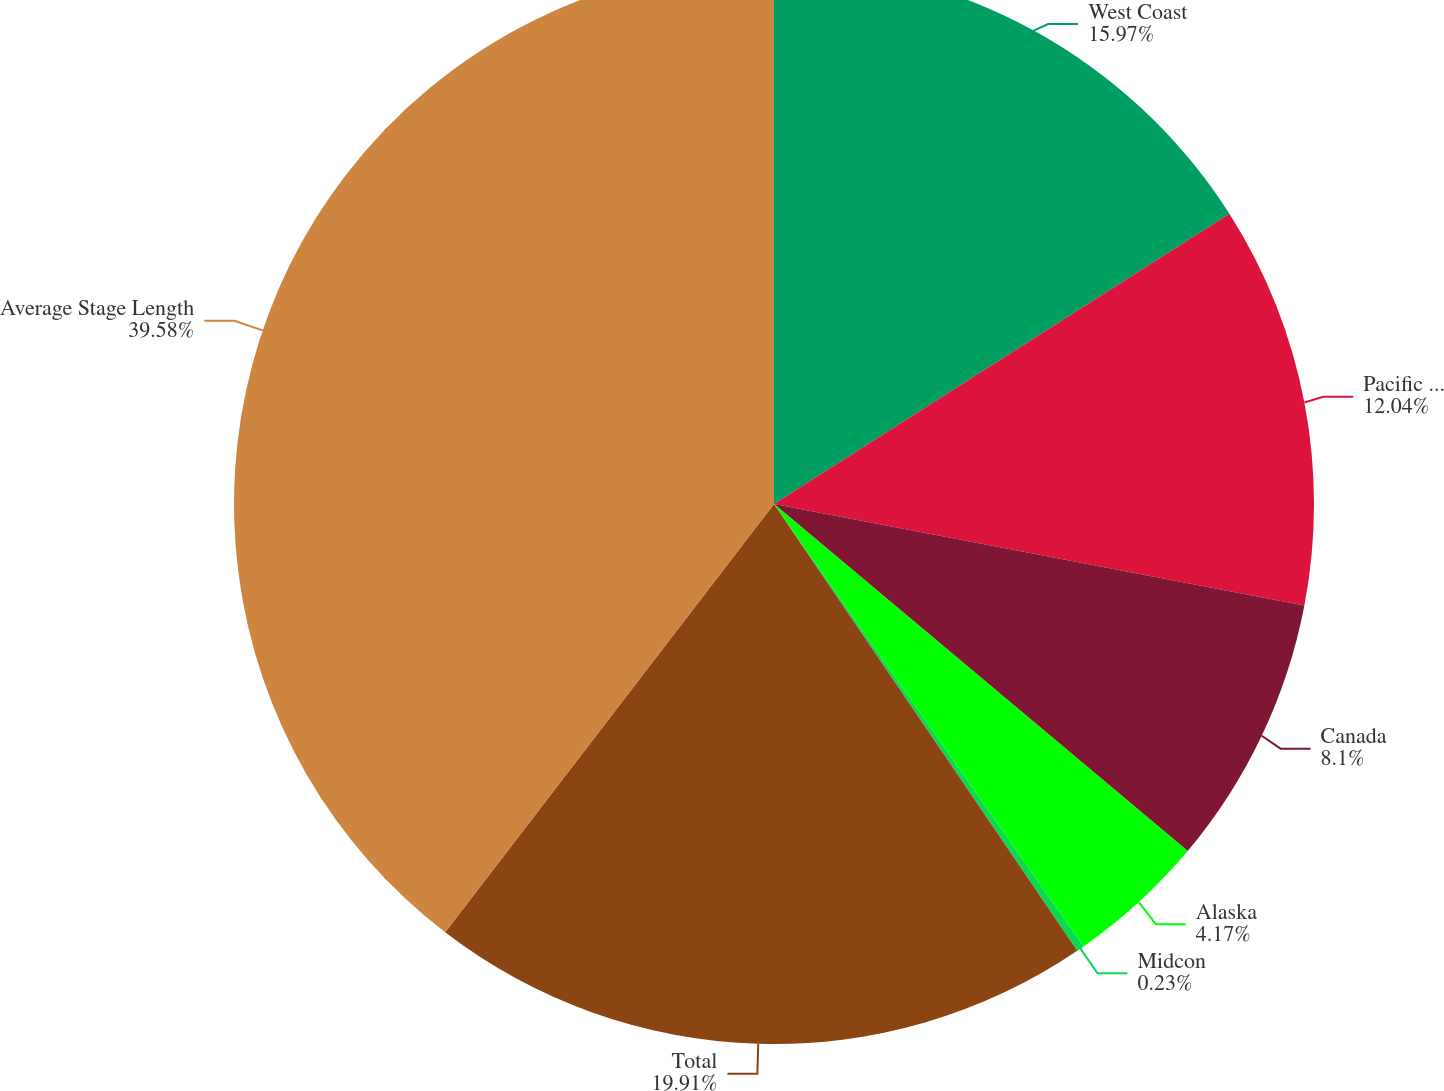Convert chart to OTSL. <chart><loc_0><loc_0><loc_500><loc_500><pie_chart><fcel>West Coast<fcel>Pacific Northwest<fcel>Canada<fcel>Alaska<fcel>Midcon<fcel>Total<fcel>Average Stage Length<nl><fcel>15.97%<fcel>12.04%<fcel>8.1%<fcel>4.17%<fcel>0.23%<fcel>19.91%<fcel>39.58%<nl></chart> 